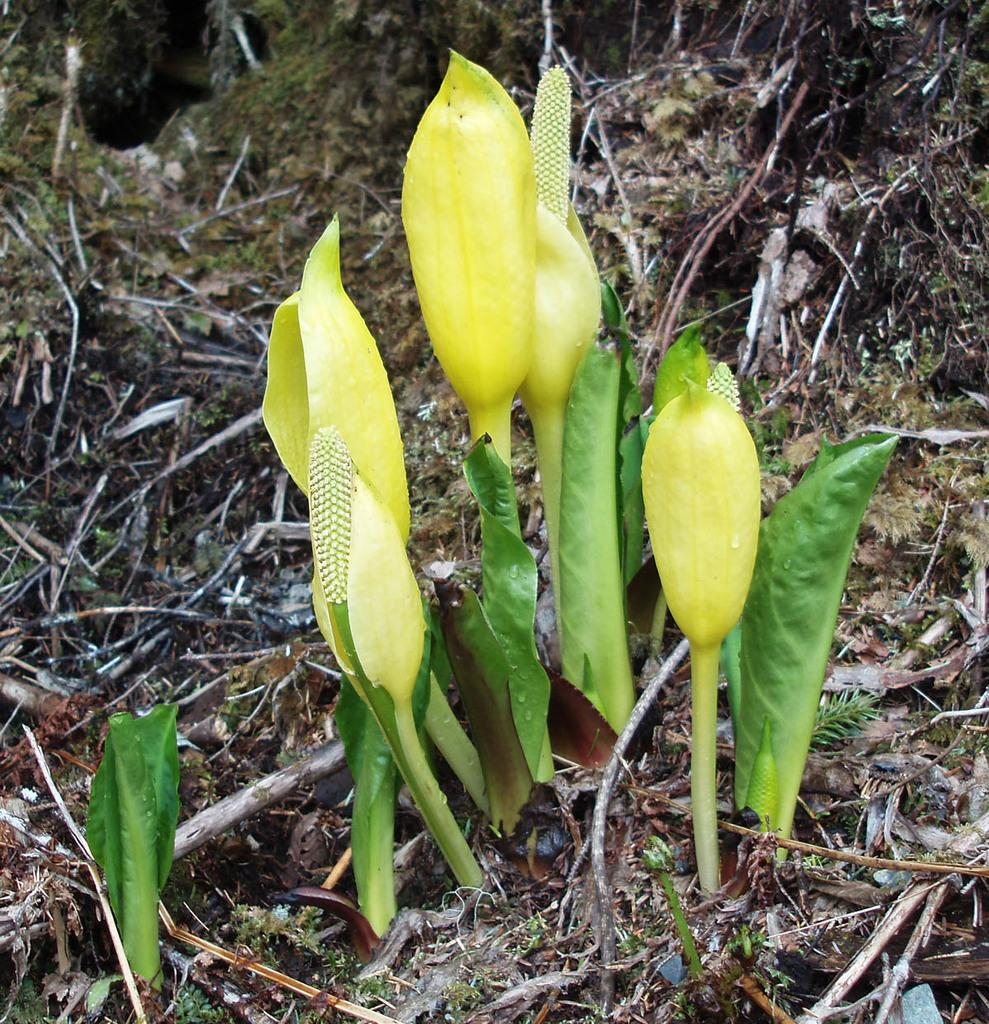What type of vegetation is present in the image? There is a plant and grass in the image. What is the condition of the plant's stems in the image? The stems of the plant appear to be dried in the image. Can you describe the bone structure of the plant in the image? There is no bone structure present in the image, as it features a plant and grass. 